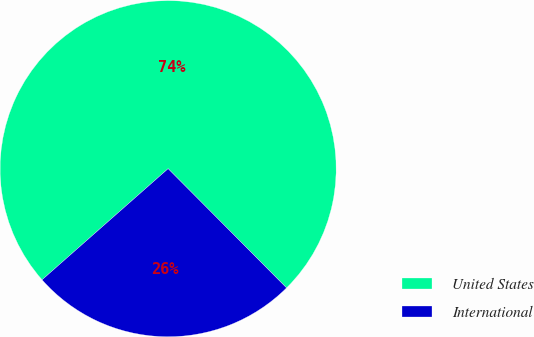Convert chart to OTSL. <chart><loc_0><loc_0><loc_500><loc_500><pie_chart><fcel>United States<fcel>International<nl><fcel>74.05%<fcel>25.95%<nl></chart> 